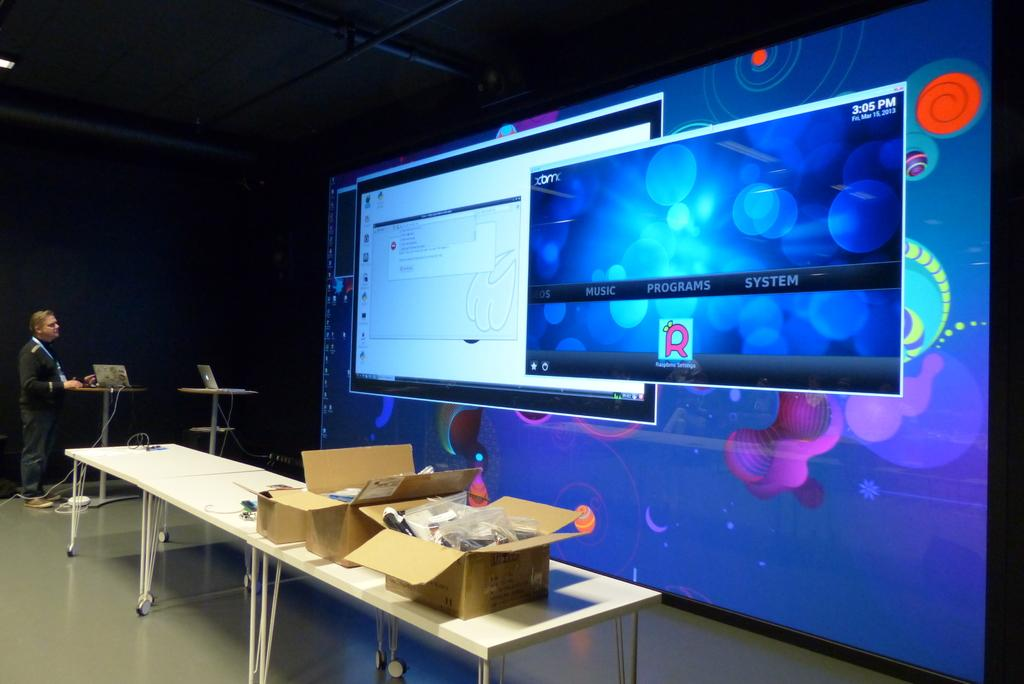<image>
Share a concise interpretation of the image provided. Large screen showing a window with the word PROGRAMS on it. 